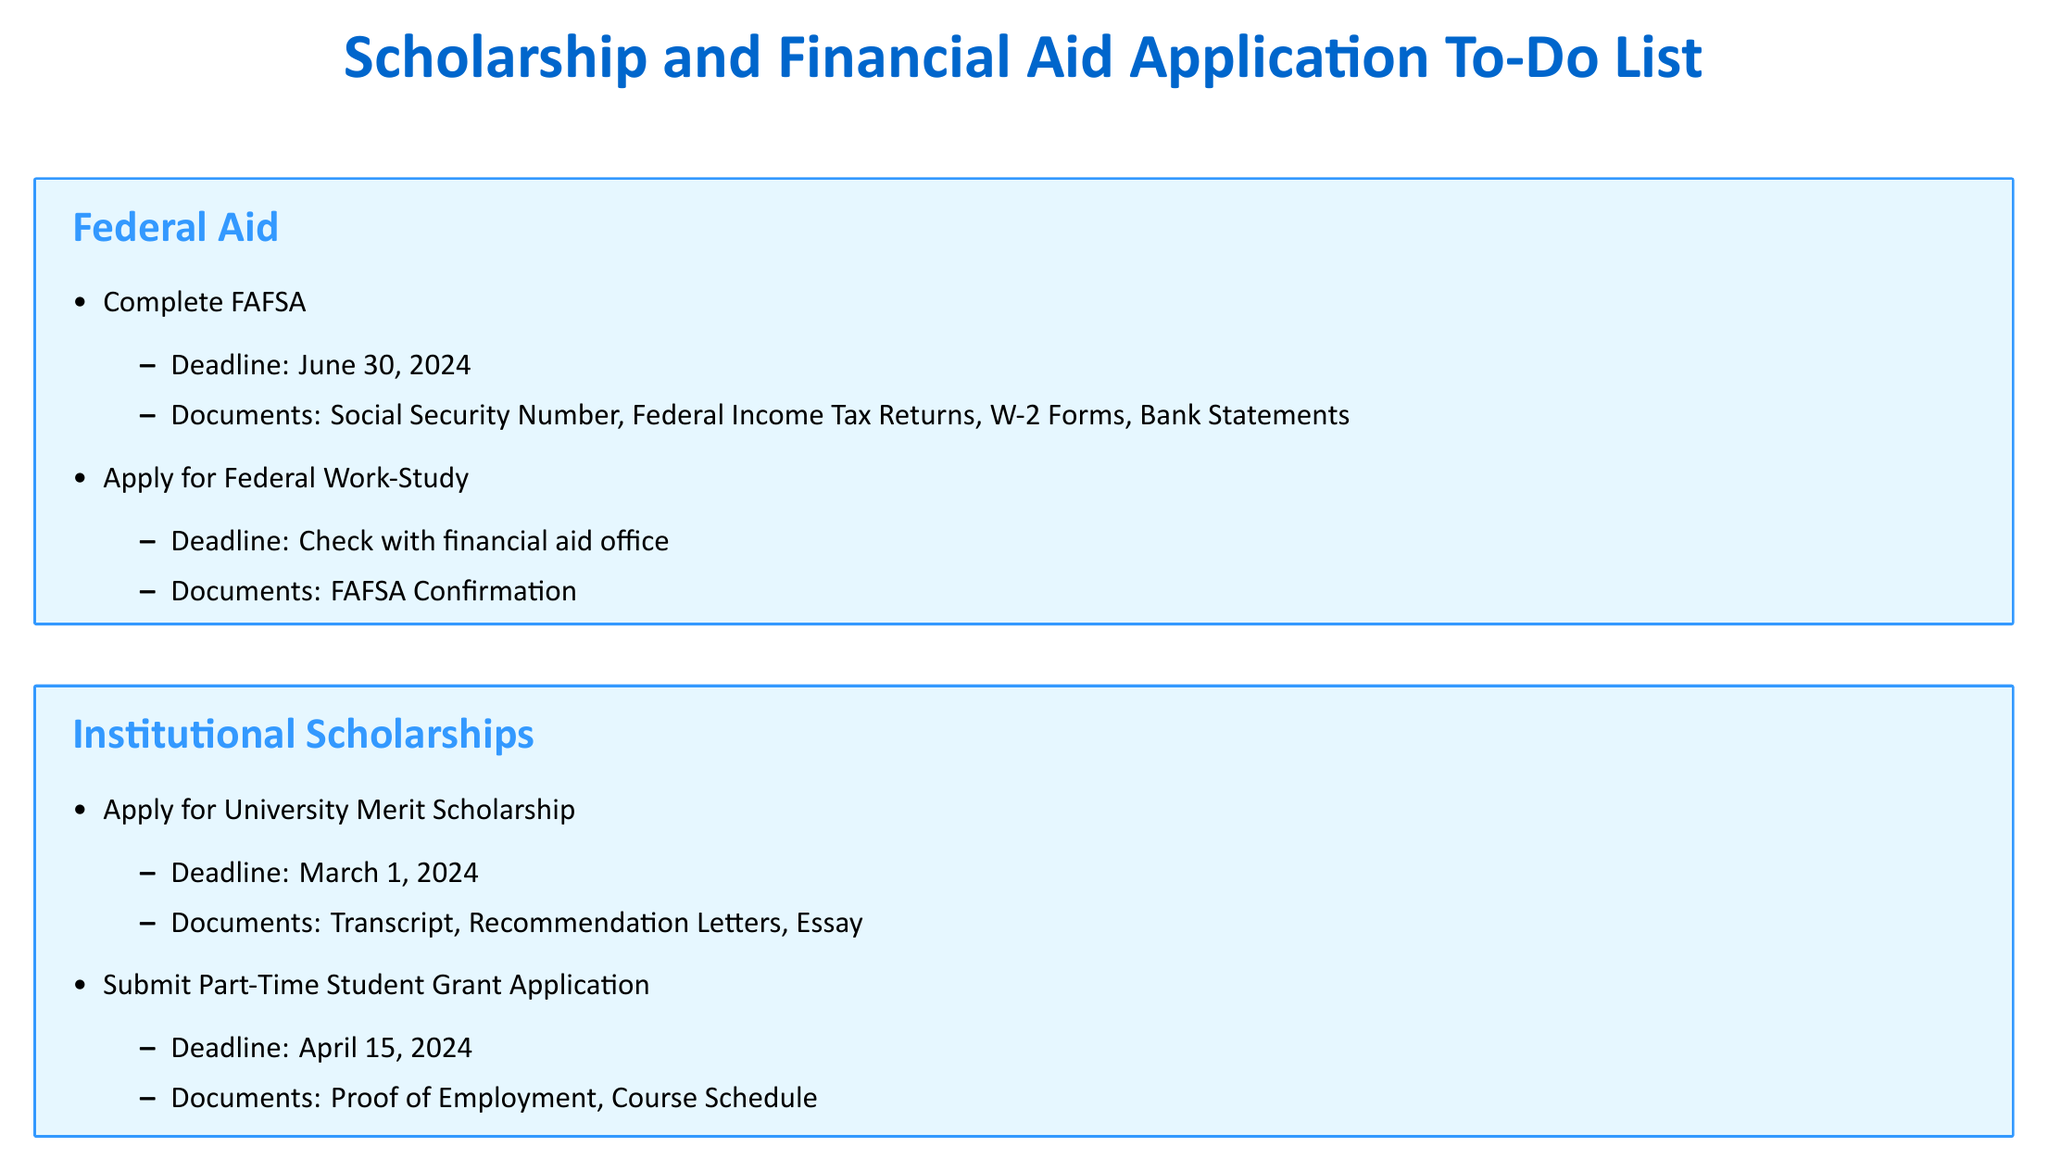what is the deadline to complete FAFSA? The deadline to complete FAFSA is mentioned in the Federal Aid section, which is June 30, 2024.
Answer: June 30, 2024 what documents are needed for the University Merit Scholarship? The documents required for the University Merit Scholarship are listed in the Institutional Scholarships section: Transcript, Recommendation Letters, and Essay.
Answer: Transcript, Recommendation Letters, Essay when is the deadline to submit the Coca-Cola Scholars Program Application? The deadline for the Coca-Cola Scholars Program Application is indicated in the External Scholarships section, specifically as October 31, 2023.
Answer: October 31, 2023 what is the task listed under Loan Management that involves researching? The task in the Loan Management section that involves researching is "Research loan repayment options."
Answer: Research loan repayment options which scholarship requires the submission of a list of extracurricular activities? The External Scholarships section states that the Coca-Cola Scholars Program Application requires a List of Extracurricular Activities among its documents.
Answer: Coca-Cola Scholars Program Application how many external scholarships are listed in the document? The number of external scholarships can be counted from the External Scholarships section: there are three listed.
Answer: three what is the deadline for the Part-Time Student Grant Application? The deadline for the Part-Time Student Grant Application is stated in the Institutional Scholarships section as April 15, 2024.
Answer: April 15, 2024 what document is needed for Federal Work-Study applications? The required document for the Federal Work-Study application is "FAFSA Confirmation," as outlined in the Federal Aid section.
Answer: FAFSA Confirmation what is the deadline for the Hispanic Scholarship Fund application? The deadline for the Hispanic Scholarship Fund application is mentioned in the External Scholarships section as February 15, 2024.
Answer: February 15, 2024 